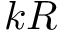<formula> <loc_0><loc_0><loc_500><loc_500>k R</formula> 